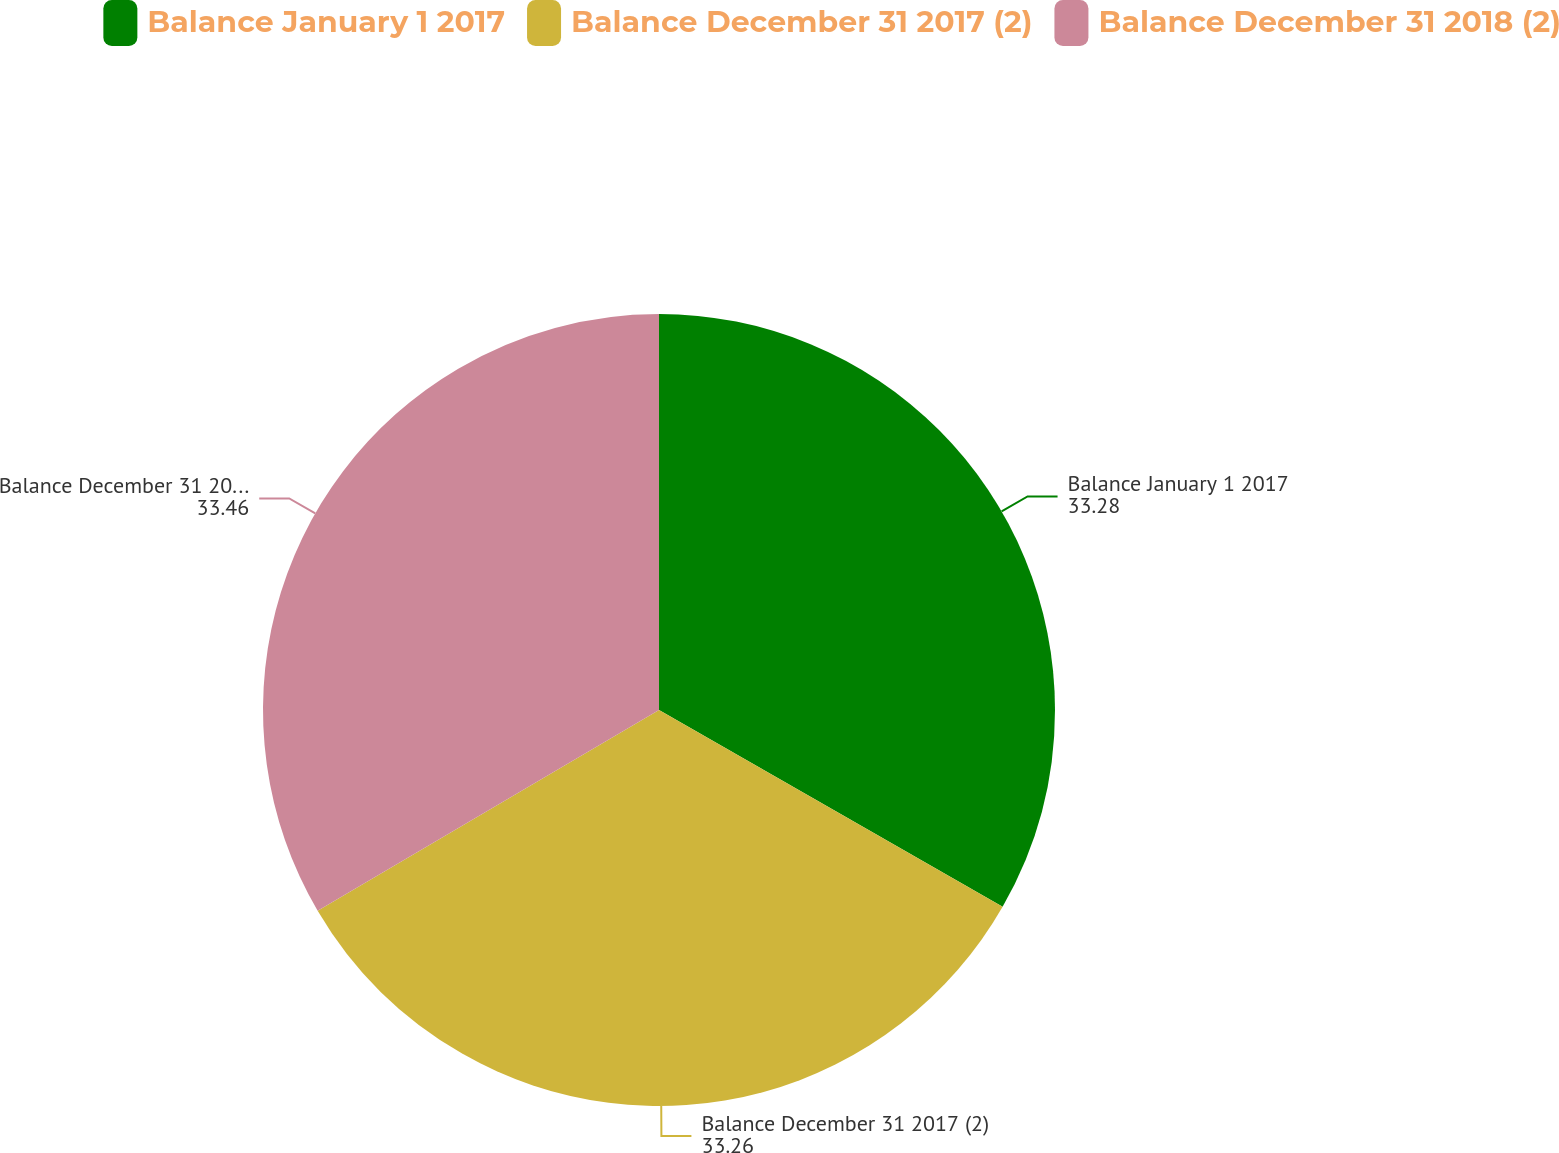Convert chart to OTSL. <chart><loc_0><loc_0><loc_500><loc_500><pie_chart><fcel>Balance January 1 2017<fcel>Balance December 31 2017 (2)<fcel>Balance December 31 2018 (2)<nl><fcel>33.28%<fcel>33.26%<fcel>33.46%<nl></chart> 